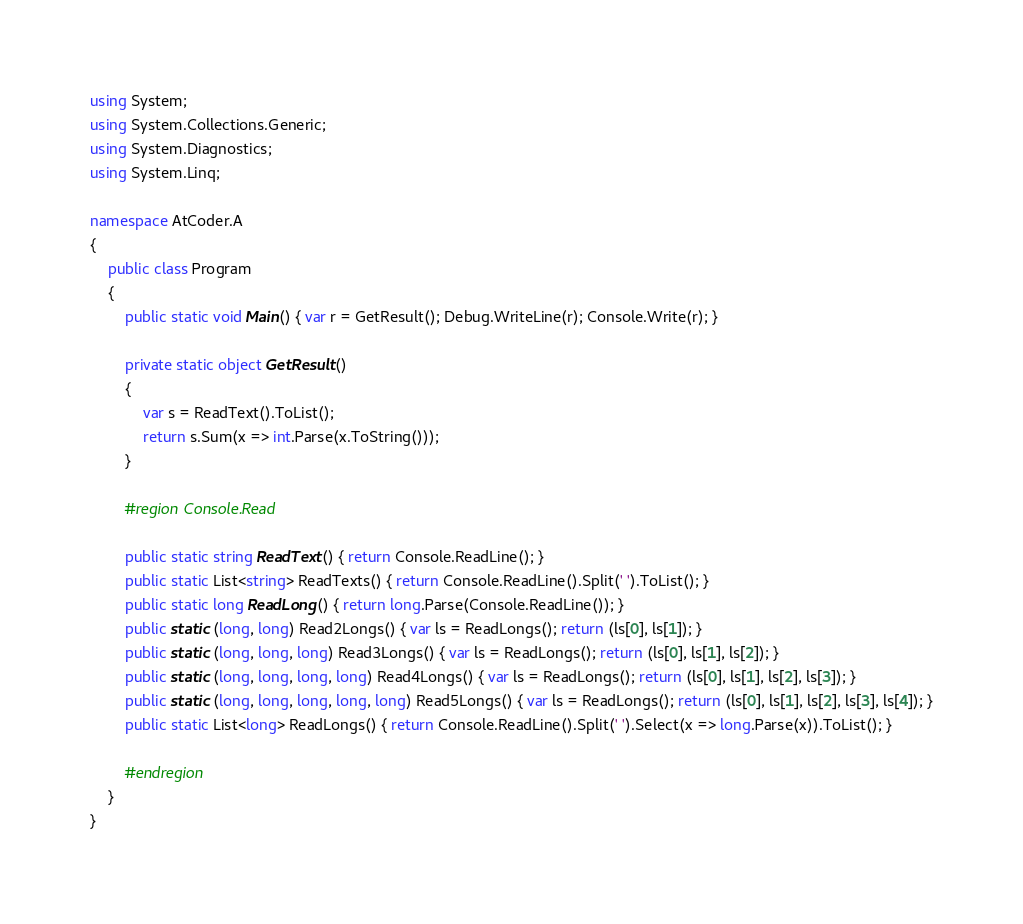<code> <loc_0><loc_0><loc_500><loc_500><_C#_>using System;
using System.Collections.Generic;
using System.Diagnostics;
using System.Linq;

namespace AtCoder.A
{
    public class Program
    {
        public static void Main() { var r = GetResult(); Debug.WriteLine(r); Console.Write(r); }

        private static object GetResult()
        {
            var s = ReadText().ToList();
            return s.Sum(x => int.Parse(x.ToString()));
        }

        #region Console.Read

        public static string ReadText() { return Console.ReadLine(); }
        public static List<string> ReadTexts() { return Console.ReadLine().Split(' ').ToList(); }
        public static long ReadLong() { return long.Parse(Console.ReadLine()); }
        public static (long, long) Read2Longs() { var ls = ReadLongs(); return (ls[0], ls[1]); }
        public static (long, long, long) Read3Longs() { var ls = ReadLongs(); return (ls[0], ls[1], ls[2]); }
        public static (long, long, long, long) Read4Longs() { var ls = ReadLongs(); return (ls[0], ls[1], ls[2], ls[3]); }
        public static (long, long, long, long, long) Read5Longs() { var ls = ReadLongs(); return (ls[0], ls[1], ls[2], ls[3], ls[4]); }
        public static List<long> ReadLongs() { return Console.ReadLine().Split(' ').Select(x => long.Parse(x)).ToList(); }

        #endregion
    }
}
</code> 